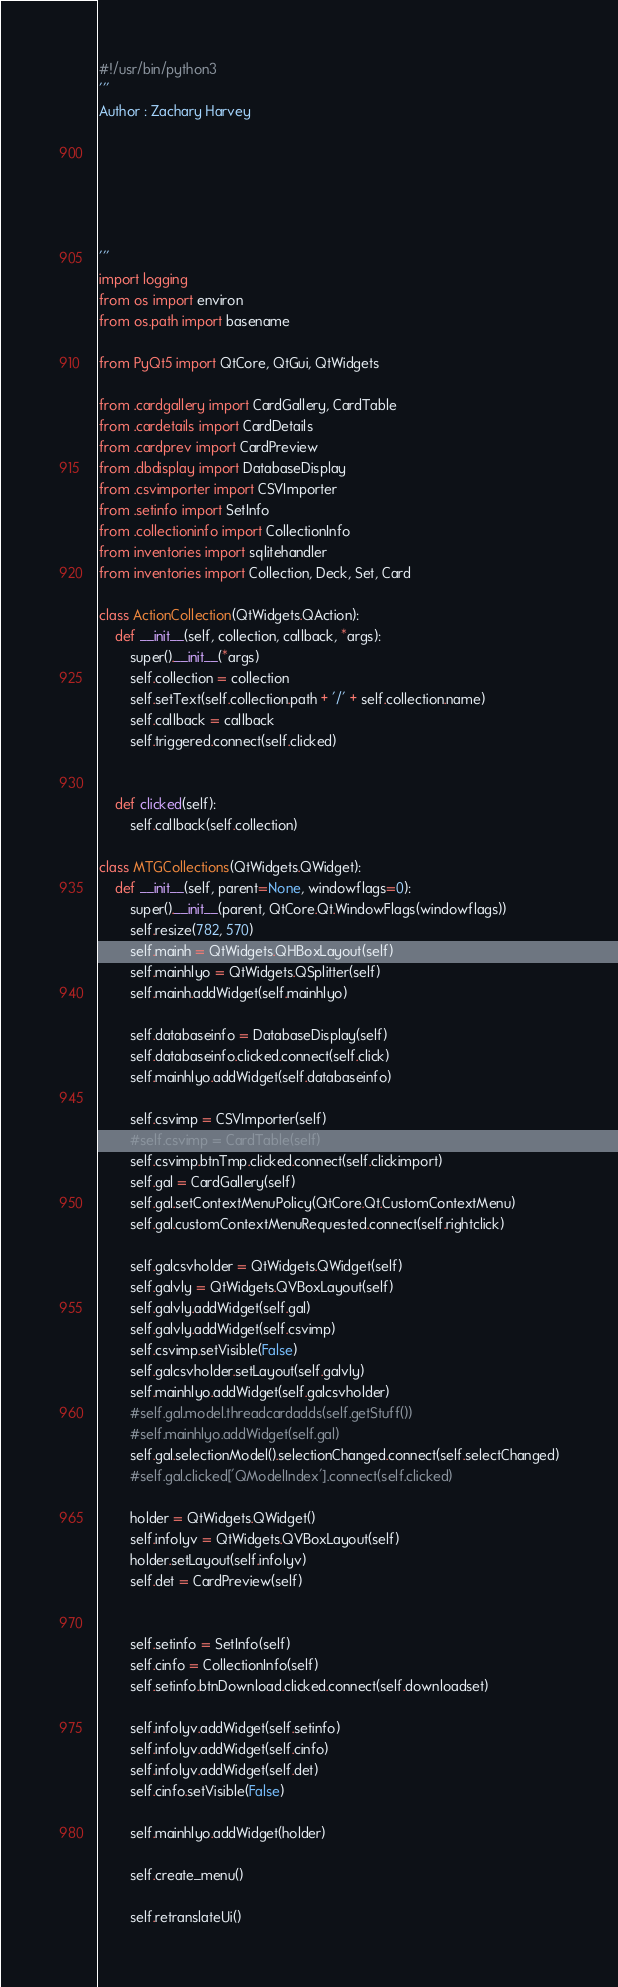Convert code to text. <code><loc_0><loc_0><loc_500><loc_500><_Python_>#!/usr/bin/python3
'''
Author : Zachary Harvey






'''
import logging
from os import environ
from os.path import basename

from PyQt5 import QtCore, QtGui, QtWidgets

from .cardgallery import CardGallery, CardTable
from .cardetails import CardDetails
from .cardprev import CardPreview
from .dbdisplay import DatabaseDisplay
from .csvimporter import CSVImporter
from .setinfo import SetInfo
from .collectioninfo import CollectionInfo
from inventories import sqlitehandler
from inventories import Collection, Deck, Set, Card

class ActionCollection(QtWidgets.QAction):
    def __init__(self, collection, callback, *args):
        super().__init__(*args)
        self.collection = collection
        self.setText(self.collection.path + '/' + self.collection.name)
        self.callback = callback
        self.triggered.connect(self.clicked)


    def clicked(self):
        self.callback(self.collection)

class MTGCollections(QtWidgets.QWidget):
    def __init__(self, parent=None, windowflags=0):
        super().__init__(parent, QtCore.Qt.WindowFlags(windowflags))
        self.resize(782, 570)
        self.mainh = QtWidgets.QHBoxLayout(self)
        self.mainhlyo = QtWidgets.QSplitter(self)
        self.mainh.addWidget(self.mainhlyo)

        self.databaseinfo = DatabaseDisplay(self)
        self.databaseinfo.clicked.connect(self.click)
        self.mainhlyo.addWidget(self.databaseinfo)

        self.csvimp = CSVImporter(self)
        #self.csvimp = CardTable(self)
        self.csvimp.btnTmp.clicked.connect(self.clickimport)
        self.gal = CardGallery(self)
        self.gal.setContextMenuPolicy(QtCore.Qt.CustomContextMenu)
        self.gal.customContextMenuRequested.connect(self.rightclick)

        self.galcsvholder = QtWidgets.QWidget(self)
        self.galvly = QtWidgets.QVBoxLayout(self)
        self.galvly.addWidget(self.gal)
        self.galvly.addWidget(self.csvimp)
        self.csvimp.setVisible(False)
        self.galcsvholder.setLayout(self.galvly)
        self.mainhlyo.addWidget(self.galcsvholder)
        #self.gal.model.threadcardadds(self.getStuff())
        #self.mainhlyo.addWidget(self.gal)
        self.gal.selectionModel().selectionChanged.connect(self.selectChanged)
        #self.gal.clicked['QModelIndex'].connect(self.clicked)

        holder = QtWidgets.QWidget()
        self.infolyv = QtWidgets.QVBoxLayout(self)
        holder.setLayout(self.infolyv)
        self.det = CardPreview(self)


        self.setinfo = SetInfo(self)
        self.cinfo = CollectionInfo(self)
        self.setinfo.btnDownload.clicked.connect(self.downloadset)

        self.infolyv.addWidget(self.setinfo)
        self.infolyv.addWidget(self.cinfo)
        self.infolyv.addWidget(self.det)
        self.cinfo.setVisible(False)

        self.mainhlyo.addWidget(holder)

        self.create_menu()

        self.retranslateUi()</code> 